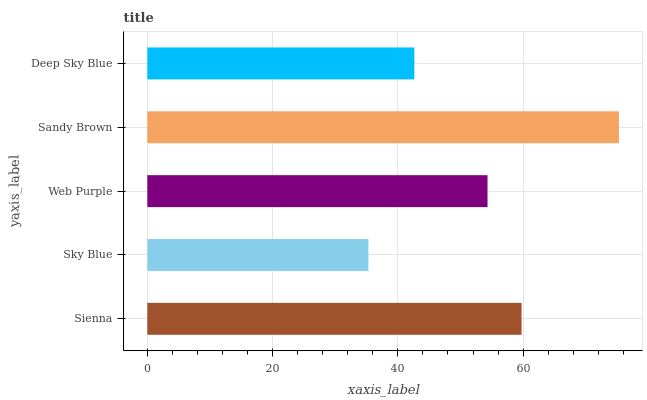Is Sky Blue the minimum?
Answer yes or no. Yes. Is Sandy Brown the maximum?
Answer yes or no. Yes. Is Web Purple the minimum?
Answer yes or no. No. Is Web Purple the maximum?
Answer yes or no. No. Is Web Purple greater than Sky Blue?
Answer yes or no. Yes. Is Sky Blue less than Web Purple?
Answer yes or no. Yes. Is Sky Blue greater than Web Purple?
Answer yes or no. No. Is Web Purple less than Sky Blue?
Answer yes or no. No. Is Web Purple the high median?
Answer yes or no. Yes. Is Web Purple the low median?
Answer yes or no. Yes. Is Deep Sky Blue the high median?
Answer yes or no. No. Is Deep Sky Blue the low median?
Answer yes or no. No. 